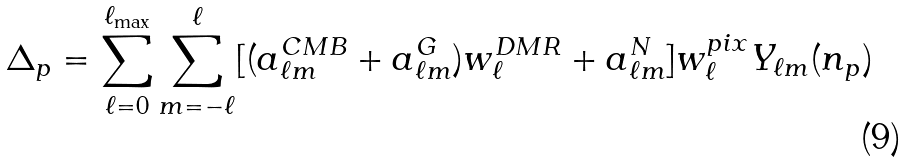Convert formula to latex. <formula><loc_0><loc_0><loc_500><loc_500>\Delta _ { p } = \sum _ { \ell = 0 } ^ { \ell _ { \max } } \sum _ { m = - \ell } ^ { \ell } [ ( a ^ { C M B } _ { \ell m } + a _ { \ell m } ^ { G } ) w ^ { D M R } _ { \ell } + a _ { \ell m } ^ { N } ] w _ { \ell } ^ { p i x } Y _ { \ell m } ( { n } _ { p } )</formula> 